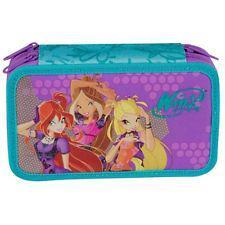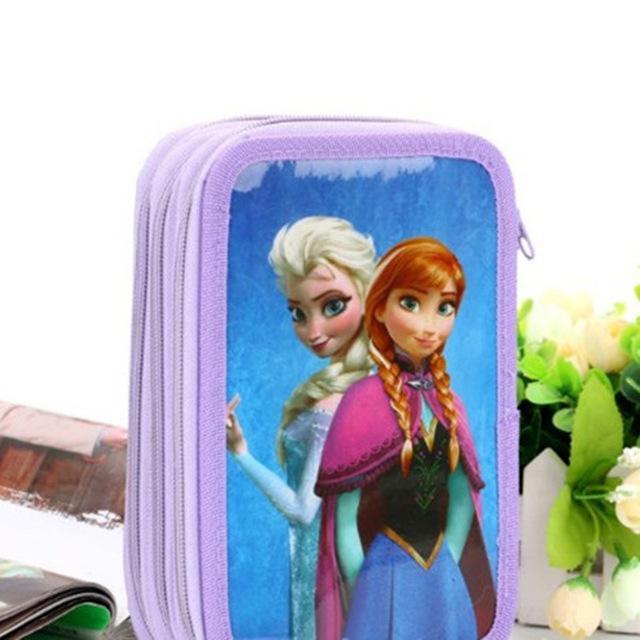The first image is the image on the left, the second image is the image on the right. Considering the images on both sides, is "There are two zippered wallets." valid? Answer yes or no. Yes. The first image is the image on the left, the second image is the image on the right. Evaluate the accuracy of this statement regarding the images: "One of the two images has a bag with the characters from Disney's Frozen on it.". Is it true? Answer yes or no. Yes. 